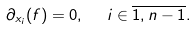<formula> <loc_0><loc_0><loc_500><loc_500>\partial _ { x _ { i } } ( f ) = 0 , \ \ i \in \overline { 1 , n - 1 } .</formula> 